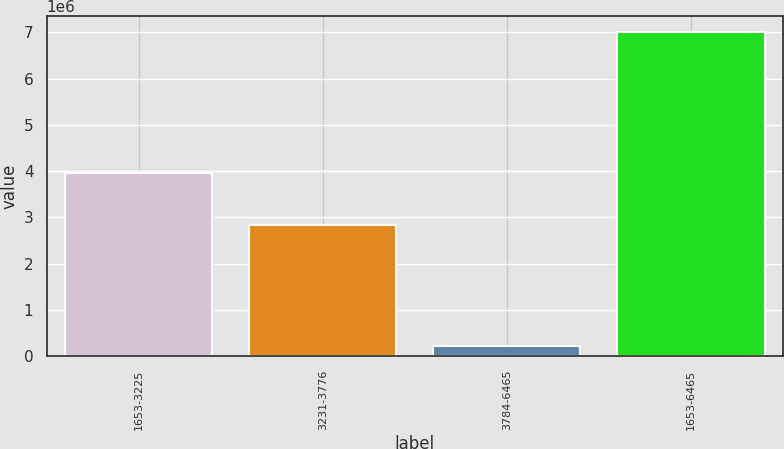Convert chart. <chart><loc_0><loc_0><loc_500><loc_500><bar_chart><fcel>1653-3225<fcel>3231-3776<fcel>3784-6465<fcel>1653-6465<nl><fcel>3.951e+06<fcel>2.83067e+06<fcel>220271<fcel>7.00194e+06<nl></chart> 